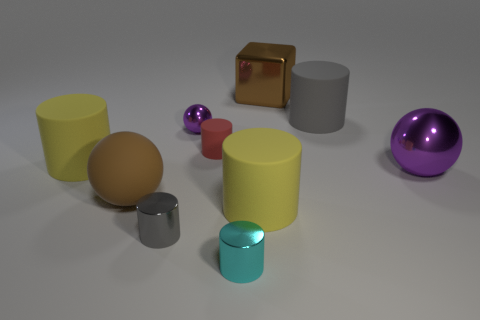There is a purple metal thing that is the same size as the cyan cylinder; what shape is it?
Your response must be concise. Sphere. Are there any other metallic spheres of the same color as the tiny ball?
Offer a very short reply. Yes. There is a large yellow matte object that is left of the tiny cyan shiny thing; what is its shape?
Ensure brevity in your answer.  Cylinder. The large metal cube is what color?
Keep it short and to the point. Brown. There is a cube that is the same material as the cyan cylinder; what color is it?
Keep it short and to the point. Brown. How many small gray objects are the same material as the cyan thing?
Provide a succinct answer. 1. What number of tiny purple shiny spheres are on the left side of the big purple object?
Provide a short and direct response. 1. Are the yellow cylinder behind the large purple metal thing and the gray cylinder that is on the left side of the large gray object made of the same material?
Offer a very short reply. No. Are there more tiny metallic spheres behind the gray metal cylinder than cylinders behind the brown block?
Your response must be concise. Yes. What is the material of the other sphere that is the same color as the small ball?
Offer a terse response. Metal. 